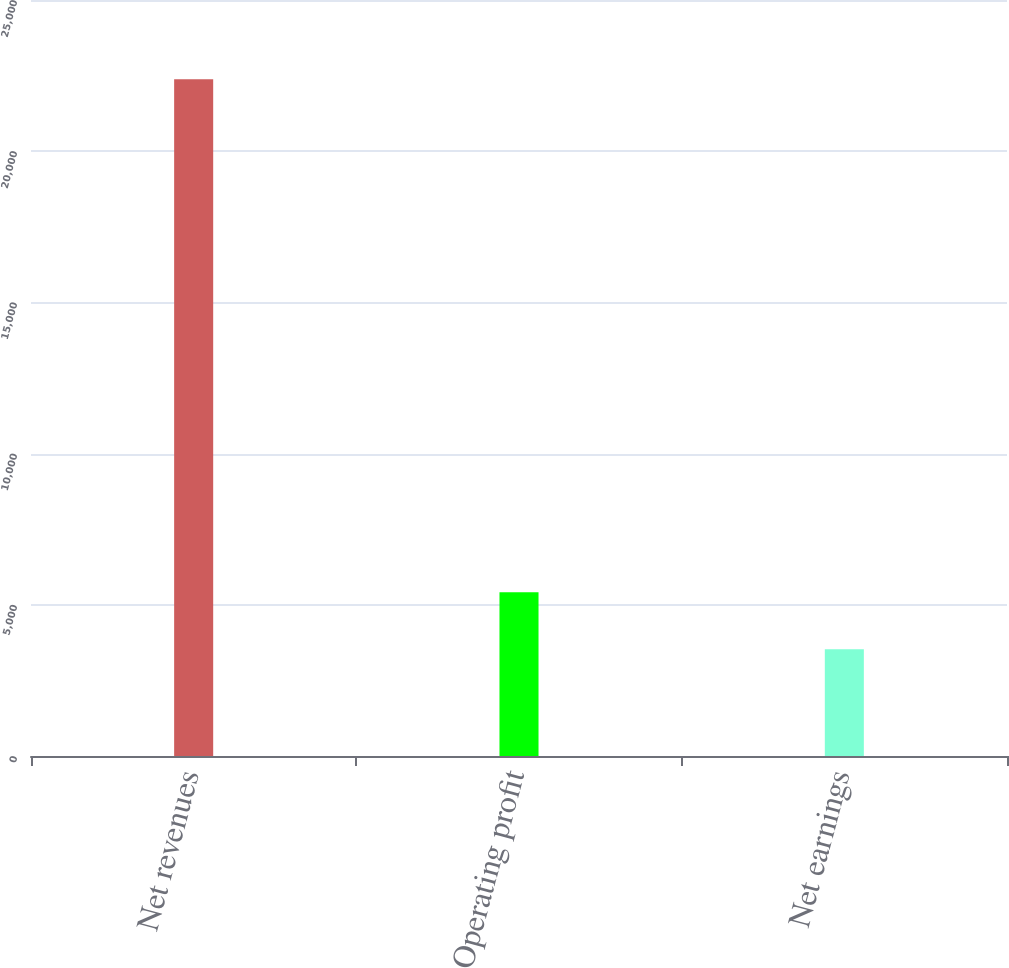<chart> <loc_0><loc_0><loc_500><loc_500><bar_chart><fcel>Net revenues<fcel>Operating profit<fcel>Net earnings<nl><fcel>22380<fcel>5416.8<fcel>3532<nl></chart> 